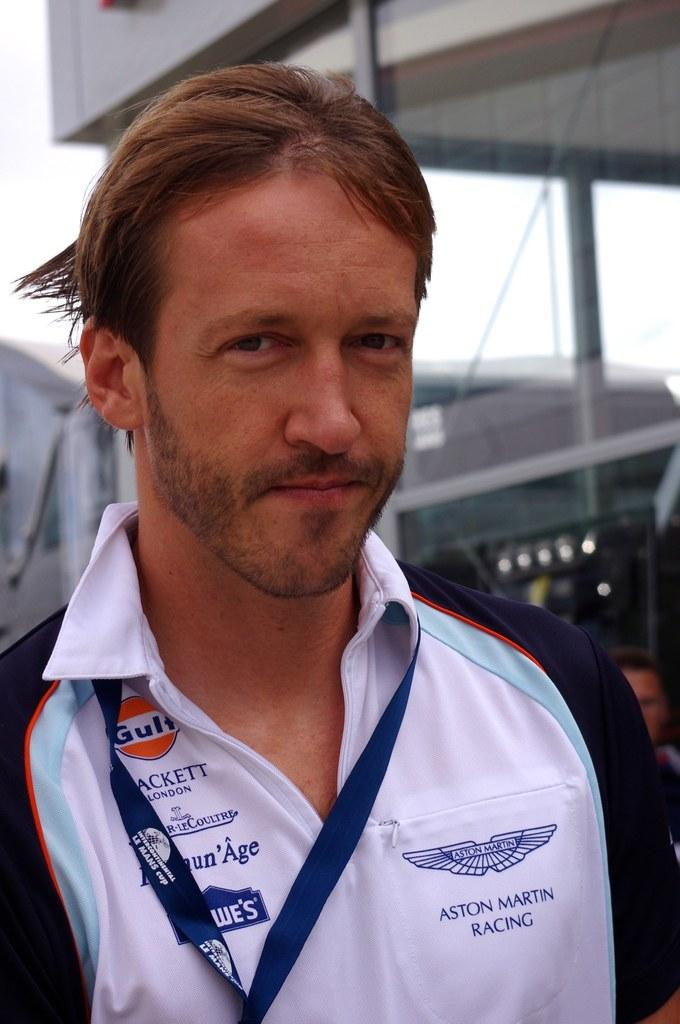What is the main subject of the image? There is a person in the image. Can you describe the person's clothing? The person is wearing a white and blue color shirt. What else can be seen in the image besides the person? There are other objects in the background of the image. What is the title of the story depicted in the image? There is no story or title present in the image; it simply shows a person wearing a white and blue color shirt with other objects in the background. 